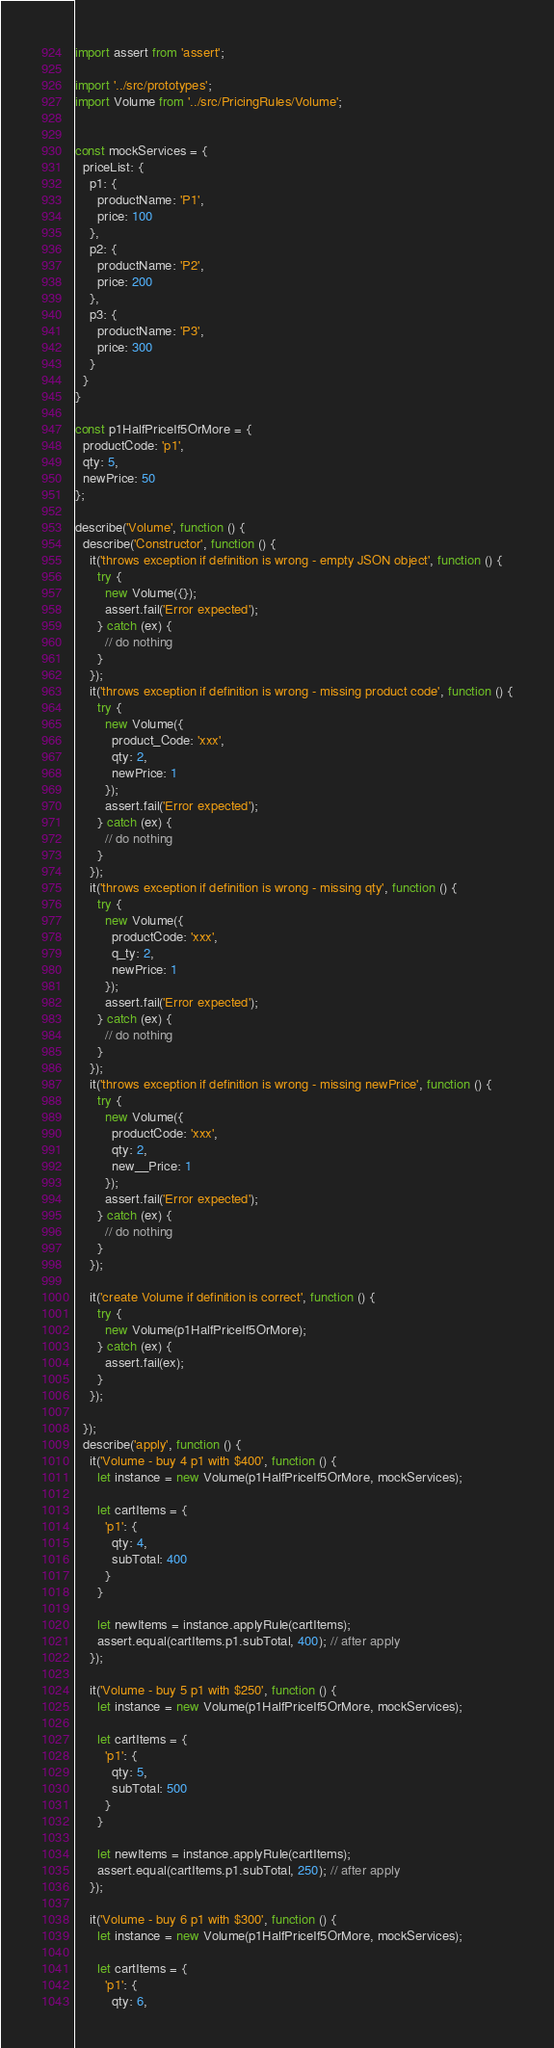Convert code to text. <code><loc_0><loc_0><loc_500><loc_500><_JavaScript_>import assert from 'assert';

import '../src/prototypes';
import Volume from '../src/PricingRules/Volume';


const mockServices = {
  priceList: {
    p1: {
      productName: 'P1',
      price: 100
    },
    p2: {
      productName: 'P2',
      price: 200
    },
    p3: {
      productName: 'P3',
      price: 300
    }
  }
}

const p1HalfPriceIf5OrMore = {
  productCode: 'p1',
  qty: 5,
  newPrice: 50
};

describe('Volume', function () {
  describe('Constructor', function () {
    it('throws exception if definition is wrong - empty JSON object', function () {
      try {
        new Volume({});
        assert.fail('Error expected');
      } catch (ex) {
        // do nothing
      }
    });
    it('throws exception if definition is wrong - missing product code', function () {
      try {
        new Volume({
          product_Code: 'xxx',
          qty: 2,
          newPrice: 1
        });
        assert.fail('Error expected');
      } catch (ex) {
        // do nothing
      }
    });
    it('throws exception if definition is wrong - missing qty', function () {
      try {
        new Volume({
          productCode: 'xxx',
          q_ty: 2,
          newPrice: 1
        });
        assert.fail('Error expected');
      } catch (ex) {
        // do nothing
      }
    });
    it('throws exception if definition is wrong - missing newPrice', function () {
      try {
        new Volume({
          productCode: 'xxx',
          qty: 2,
          new__Price: 1
        });
        assert.fail('Error expected');
      } catch (ex) {
        // do nothing
      }
    });

    it('create Volume if definition is correct', function () {
      try {
        new Volume(p1HalfPriceIf5OrMore);
      } catch (ex) {
        assert.fail(ex);
      }
    });

  });
  describe('apply', function () {
    it('Volume - buy 4 p1 with $400', function () {
      let instance = new Volume(p1HalfPriceIf5OrMore, mockServices);

      let cartItems = {
        'p1': {
          qty: 4,
          subTotal: 400
        }
      }

      let newItems = instance.applyRule(cartItems);
      assert.equal(cartItems.p1.subTotal, 400); // after apply
    });

    it('Volume - buy 5 p1 with $250', function () {
      let instance = new Volume(p1HalfPriceIf5OrMore, mockServices);

      let cartItems = {
        'p1': {
          qty: 5,
          subTotal: 500
        }
      }

      let newItems = instance.applyRule(cartItems);
      assert.equal(cartItems.p1.subTotal, 250); // after apply
    });

    it('Volume - buy 6 p1 with $300', function () {
      let instance = new Volume(p1HalfPriceIf5OrMore, mockServices);

      let cartItems = {
        'p1': {
          qty: 6,</code> 